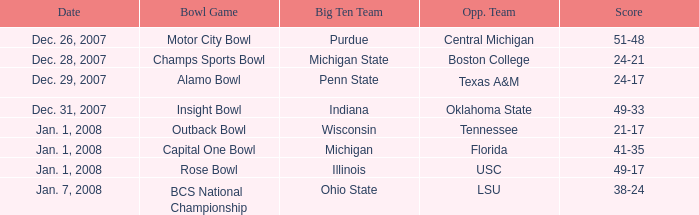Who was Purdue's opponent? Central Michigan. 